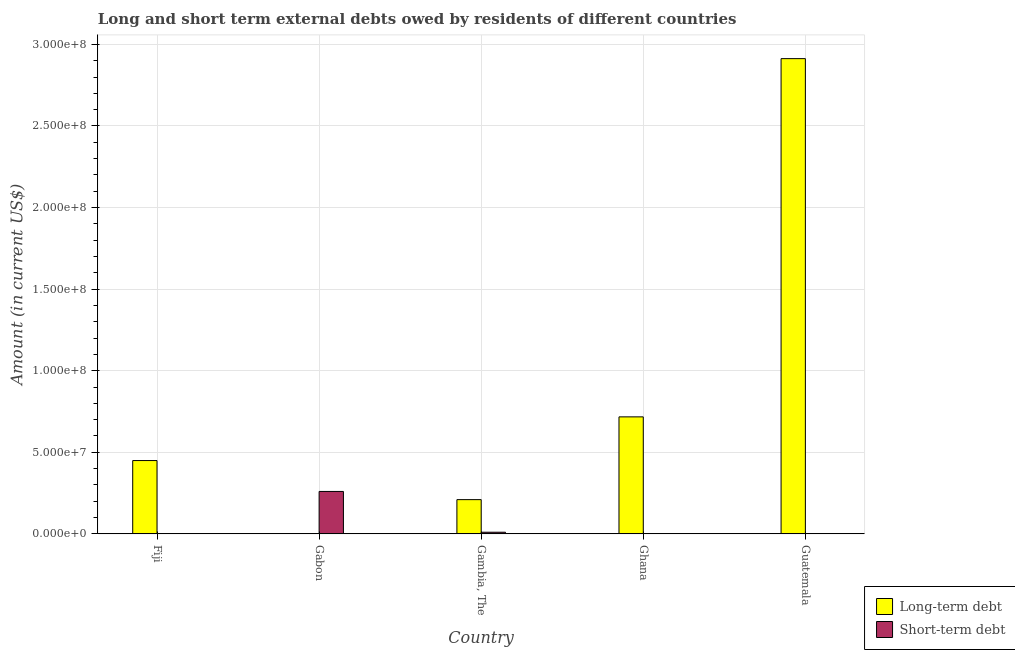How many different coloured bars are there?
Give a very brief answer. 2. How many bars are there on the 3rd tick from the left?
Give a very brief answer. 2. How many bars are there on the 3rd tick from the right?
Your answer should be compact. 2. What is the label of the 2nd group of bars from the left?
Provide a short and direct response. Gabon. In how many cases, is the number of bars for a given country not equal to the number of legend labels?
Your answer should be very brief. 4. What is the short-term debts owed by residents in Fiji?
Provide a succinct answer. 0. Across all countries, what is the maximum long-term debts owed by residents?
Your answer should be compact. 2.91e+08. In which country was the short-term debts owed by residents maximum?
Provide a short and direct response. Gabon. What is the total long-term debts owed by residents in the graph?
Ensure brevity in your answer.  4.29e+08. What is the difference between the long-term debts owed by residents in Ghana and that in Guatemala?
Offer a very short reply. -2.20e+08. What is the difference between the short-term debts owed by residents in Gambia, The and the long-term debts owed by residents in Guatemala?
Provide a succinct answer. -2.90e+08. What is the average long-term debts owed by residents per country?
Ensure brevity in your answer.  8.58e+07. In how many countries, is the short-term debts owed by residents greater than 170000000 US$?
Your answer should be very brief. 0. What is the ratio of the long-term debts owed by residents in Fiji to that in Gambia, The?
Keep it short and to the point. 2.14. What is the difference between the highest and the second highest long-term debts owed by residents?
Offer a terse response. 2.20e+08. What is the difference between the highest and the lowest long-term debts owed by residents?
Keep it short and to the point. 2.91e+08. How many countries are there in the graph?
Ensure brevity in your answer.  5. Does the graph contain any zero values?
Give a very brief answer. Yes. Does the graph contain grids?
Ensure brevity in your answer.  Yes. Where does the legend appear in the graph?
Ensure brevity in your answer.  Bottom right. How many legend labels are there?
Give a very brief answer. 2. What is the title of the graph?
Your response must be concise. Long and short term external debts owed by residents of different countries. Does "Lowest 10% of population" appear as one of the legend labels in the graph?
Your response must be concise. No. What is the Amount (in current US$) of Long-term debt in Fiji?
Offer a terse response. 4.49e+07. What is the Amount (in current US$) of Short-term debt in Fiji?
Give a very brief answer. 0. What is the Amount (in current US$) in Long-term debt in Gabon?
Provide a succinct answer. 0. What is the Amount (in current US$) of Short-term debt in Gabon?
Offer a very short reply. 2.60e+07. What is the Amount (in current US$) in Long-term debt in Gambia, The?
Make the answer very short. 2.10e+07. What is the Amount (in current US$) of Short-term debt in Gambia, The?
Your response must be concise. 1.00e+06. What is the Amount (in current US$) of Long-term debt in Ghana?
Keep it short and to the point. 7.17e+07. What is the Amount (in current US$) in Short-term debt in Ghana?
Provide a short and direct response. 0. What is the Amount (in current US$) of Long-term debt in Guatemala?
Your response must be concise. 2.91e+08. What is the Amount (in current US$) of Short-term debt in Guatemala?
Ensure brevity in your answer.  0. Across all countries, what is the maximum Amount (in current US$) of Long-term debt?
Your answer should be very brief. 2.91e+08. Across all countries, what is the maximum Amount (in current US$) in Short-term debt?
Your answer should be compact. 2.60e+07. Across all countries, what is the minimum Amount (in current US$) in Long-term debt?
Make the answer very short. 0. Across all countries, what is the minimum Amount (in current US$) of Short-term debt?
Offer a very short reply. 0. What is the total Amount (in current US$) of Long-term debt in the graph?
Keep it short and to the point. 4.29e+08. What is the total Amount (in current US$) of Short-term debt in the graph?
Ensure brevity in your answer.  2.70e+07. What is the difference between the Amount (in current US$) of Long-term debt in Fiji and that in Gambia, The?
Your answer should be compact. 2.39e+07. What is the difference between the Amount (in current US$) in Long-term debt in Fiji and that in Ghana?
Offer a terse response. -2.68e+07. What is the difference between the Amount (in current US$) of Long-term debt in Fiji and that in Guatemala?
Make the answer very short. -2.46e+08. What is the difference between the Amount (in current US$) of Short-term debt in Gabon and that in Gambia, The?
Your response must be concise. 2.50e+07. What is the difference between the Amount (in current US$) of Long-term debt in Gambia, The and that in Ghana?
Ensure brevity in your answer.  -5.07e+07. What is the difference between the Amount (in current US$) of Long-term debt in Gambia, The and that in Guatemala?
Provide a succinct answer. -2.70e+08. What is the difference between the Amount (in current US$) in Long-term debt in Ghana and that in Guatemala?
Provide a succinct answer. -2.20e+08. What is the difference between the Amount (in current US$) in Long-term debt in Fiji and the Amount (in current US$) in Short-term debt in Gabon?
Provide a short and direct response. 1.89e+07. What is the difference between the Amount (in current US$) in Long-term debt in Fiji and the Amount (in current US$) in Short-term debt in Gambia, The?
Ensure brevity in your answer.  4.39e+07. What is the average Amount (in current US$) in Long-term debt per country?
Offer a terse response. 8.58e+07. What is the average Amount (in current US$) in Short-term debt per country?
Your response must be concise. 5.40e+06. What is the difference between the Amount (in current US$) in Long-term debt and Amount (in current US$) in Short-term debt in Gambia, The?
Provide a succinct answer. 2.00e+07. What is the ratio of the Amount (in current US$) in Long-term debt in Fiji to that in Gambia, The?
Your response must be concise. 2.14. What is the ratio of the Amount (in current US$) of Long-term debt in Fiji to that in Ghana?
Your answer should be compact. 0.63. What is the ratio of the Amount (in current US$) in Long-term debt in Fiji to that in Guatemala?
Your answer should be compact. 0.15. What is the ratio of the Amount (in current US$) in Long-term debt in Gambia, The to that in Ghana?
Your response must be concise. 0.29. What is the ratio of the Amount (in current US$) of Long-term debt in Gambia, The to that in Guatemala?
Provide a short and direct response. 0.07. What is the ratio of the Amount (in current US$) of Long-term debt in Ghana to that in Guatemala?
Your answer should be very brief. 0.25. What is the difference between the highest and the second highest Amount (in current US$) of Long-term debt?
Offer a terse response. 2.20e+08. What is the difference between the highest and the lowest Amount (in current US$) in Long-term debt?
Keep it short and to the point. 2.91e+08. What is the difference between the highest and the lowest Amount (in current US$) in Short-term debt?
Your response must be concise. 2.60e+07. 